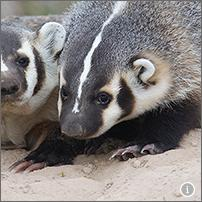What behaviors might these badgers be showing in this photo? In the image, the badgers appear to be engaged in typical foraging behavior. Their posture and focus on the ground suggest they are using their keen sense of smell to locate food beneath the surface, possibly insects or small animals. The dirt around them indicates recent digging activity, which is a common behavior when badgers are searching for underground prey or creating burrows. How do these behaviors benefit the badgers' survival? These foraging and digging behaviors are vital for the badgers’ survival as they help them access a diverse range of foods that might not be available on the surface, enhancing their dietary intake. Digging also plays a crucial role in creating shelters, which protect them from predators and harsh weather conditions, thereby increasing their chances of survival in their natural habitats. 